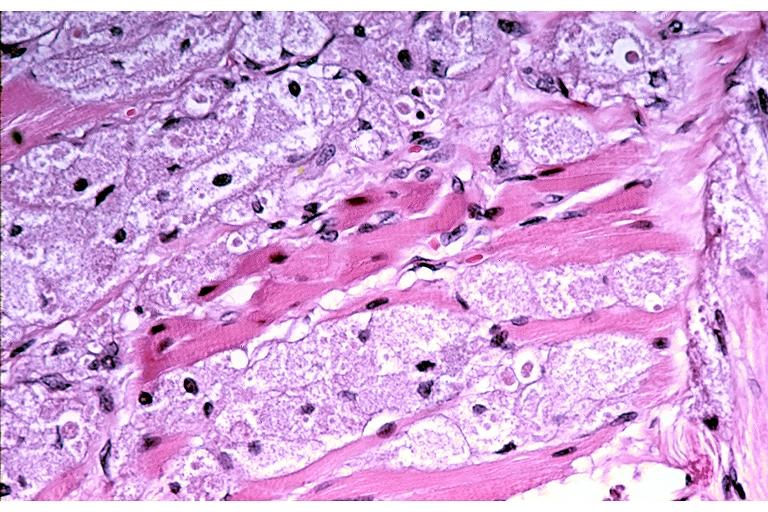does this image show granular cell tumor?
Answer the question using a single word or phrase. Yes 